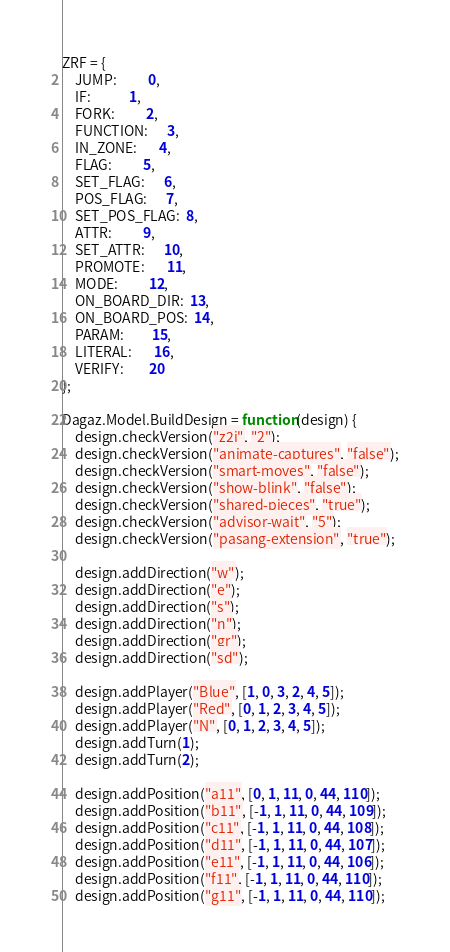Convert code to text. <code><loc_0><loc_0><loc_500><loc_500><_JavaScript_>ZRF = {
    JUMP:          0,
    IF:            1,
    FORK:          2,
    FUNCTION:      3,
    IN_ZONE:       4,
    FLAG:          5,
    SET_FLAG:      6,
    POS_FLAG:      7,
    SET_POS_FLAG:  8,
    ATTR:          9,
    SET_ATTR:      10,
    PROMOTE:       11,
    MODE:          12,
    ON_BOARD_DIR:  13,
    ON_BOARD_POS:  14,
    PARAM:         15,
    LITERAL:       16,
    VERIFY:        20
};

Dagaz.Model.BuildDesign = function(design) {
    design.checkVersion("z2j", "2");
    design.checkVersion("animate-captures", "false");
    design.checkVersion("smart-moves", "false");
    design.checkVersion("show-blink", "false");
    design.checkVersion("shared-pieces", "true");
    design.checkVersion("advisor-wait", "5");
    design.checkVersion("pasang-extension", "true");

    design.addDirection("w");
    design.addDirection("e");
    design.addDirection("s");
    design.addDirection("n");
    design.addDirection("gr");
    design.addDirection("sd");

    design.addPlayer("Blue", [1, 0, 3, 2, 4, 5]);
    design.addPlayer("Red", [0, 1, 2, 3, 4, 5]);
    design.addPlayer("N", [0, 1, 2, 3, 4, 5]);
    design.addTurn(1);
    design.addTurn(2);

    design.addPosition("a11", [0, 1, 11, 0, 44, 110]);
    design.addPosition("b11", [-1, 1, 11, 0, 44, 109]);
    design.addPosition("c11", [-1, 1, 11, 0, 44, 108]);
    design.addPosition("d11", [-1, 1, 11, 0, 44, 107]);
    design.addPosition("e11", [-1, 1, 11, 0, 44, 106]);
    design.addPosition("f11", [-1, 1, 11, 0, 44, 110]);
    design.addPosition("g11", [-1, 1, 11, 0, 44, 110]);</code> 